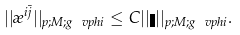Convert formula to latex. <formula><loc_0><loc_0><loc_500><loc_500>| | \rho ^ { i \bar { j } } | | _ { p ; M ; g _ { \ } v p h i } \leq C | | \eta | | _ { p ; M ; g _ { \ } v p h i } .</formula> 